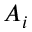Convert formula to latex. <formula><loc_0><loc_0><loc_500><loc_500>A _ { i }</formula> 